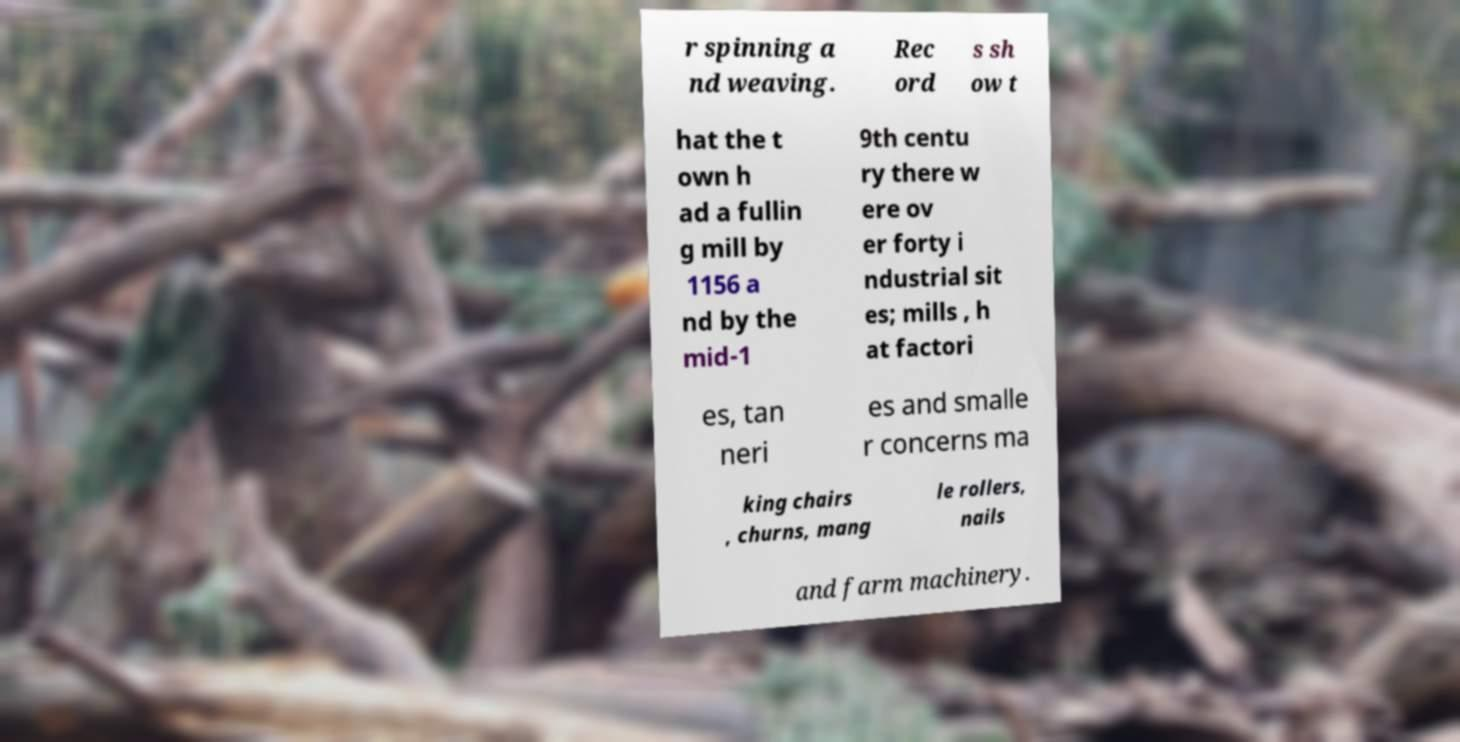Please identify and transcribe the text found in this image. r spinning a nd weaving. Rec ord s sh ow t hat the t own h ad a fullin g mill by 1156 a nd by the mid-1 9th centu ry there w ere ov er forty i ndustrial sit es; mills , h at factori es, tan neri es and smalle r concerns ma king chairs , churns, mang le rollers, nails and farm machinery. 